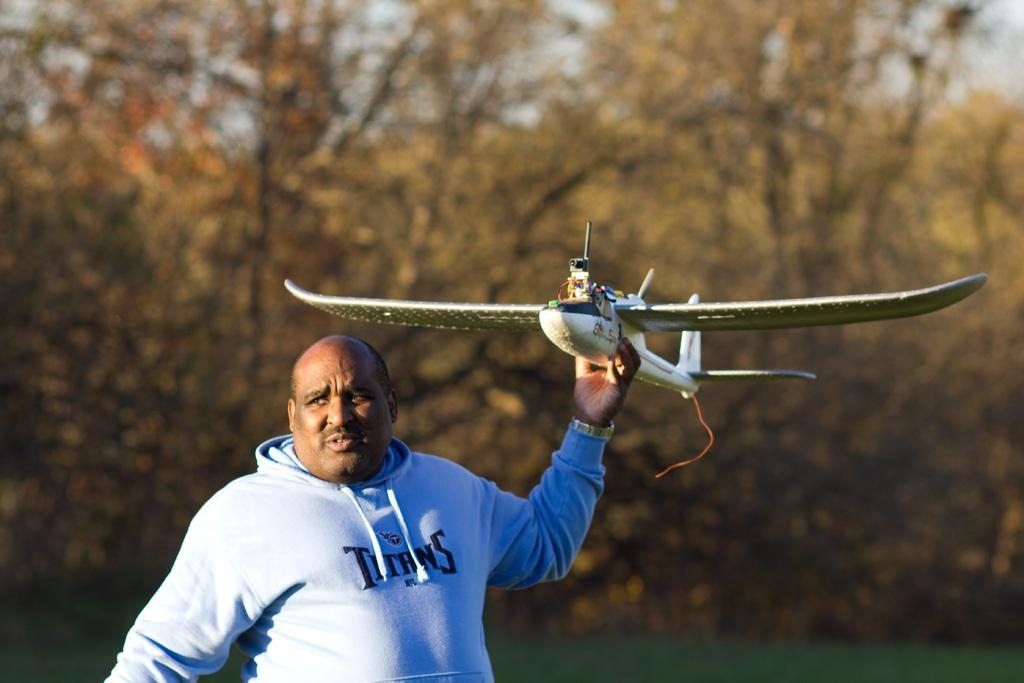Provide a one-sentence caption for the provided image. A Titans fan is holding a model airplane. 